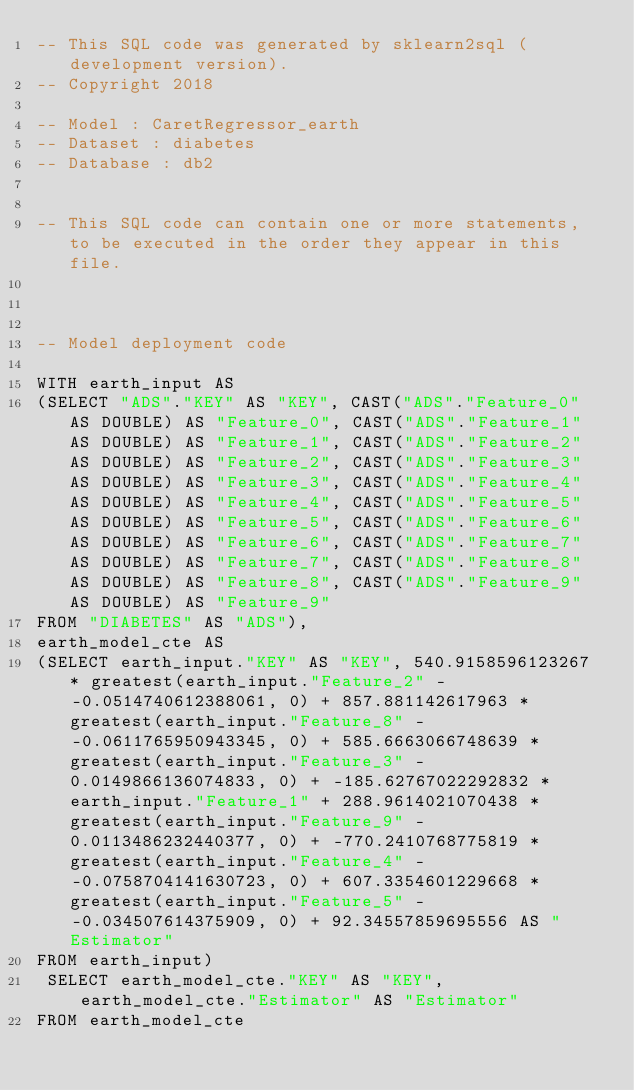Convert code to text. <code><loc_0><loc_0><loc_500><loc_500><_SQL_>-- This SQL code was generated by sklearn2sql (development version).
-- Copyright 2018

-- Model : CaretRegressor_earth
-- Dataset : diabetes
-- Database : db2


-- This SQL code can contain one or more statements, to be executed in the order they appear in this file.



-- Model deployment code

WITH earth_input AS 
(SELECT "ADS"."KEY" AS "KEY", CAST("ADS"."Feature_0" AS DOUBLE) AS "Feature_0", CAST("ADS"."Feature_1" AS DOUBLE) AS "Feature_1", CAST("ADS"."Feature_2" AS DOUBLE) AS "Feature_2", CAST("ADS"."Feature_3" AS DOUBLE) AS "Feature_3", CAST("ADS"."Feature_4" AS DOUBLE) AS "Feature_4", CAST("ADS"."Feature_5" AS DOUBLE) AS "Feature_5", CAST("ADS"."Feature_6" AS DOUBLE) AS "Feature_6", CAST("ADS"."Feature_7" AS DOUBLE) AS "Feature_7", CAST("ADS"."Feature_8" AS DOUBLE) AS "Feature_8", CAST("ADS"."Feature_9" AS DOUBLE) AS "Feature_9" 
FROM "DIABETES" AS "ADS"), 
earth_model_cte AS 
(SELECT earth_input."KEY" AS "KEY", 540.9158596123267 * greatest(earth_input."Feature_2" - -0.0514740612388061, 0) + 857.881142617963 * greatest(earth_input."Feature_8" - -0.0611765950943345, 0) + 585.6663066748639 * greatest(earth_input."Feature_3" - 0.0149866136074833, 0) + -185.62767022292832 * earth_input."Feature_1" + 288.9614021070438 * greatest(earth_input."Feature_9" - 0.0113486232440377, 0) + -770.2410768775819 * greatest(earth_input."Feature_4" - -0.0758704141630723, 0) + 607.3354601229668 * greatest(earth_input."Feature_5" - -0.034507614375909, 0) + 92.34557859695556 AS "Estimator" 
FROM earth_input)
 SELECT earth_model_cte."KEY" AS "KEY", earth_model_cte."Estimator" AS "Estimator" 
FROM earth_model_cte</code> 